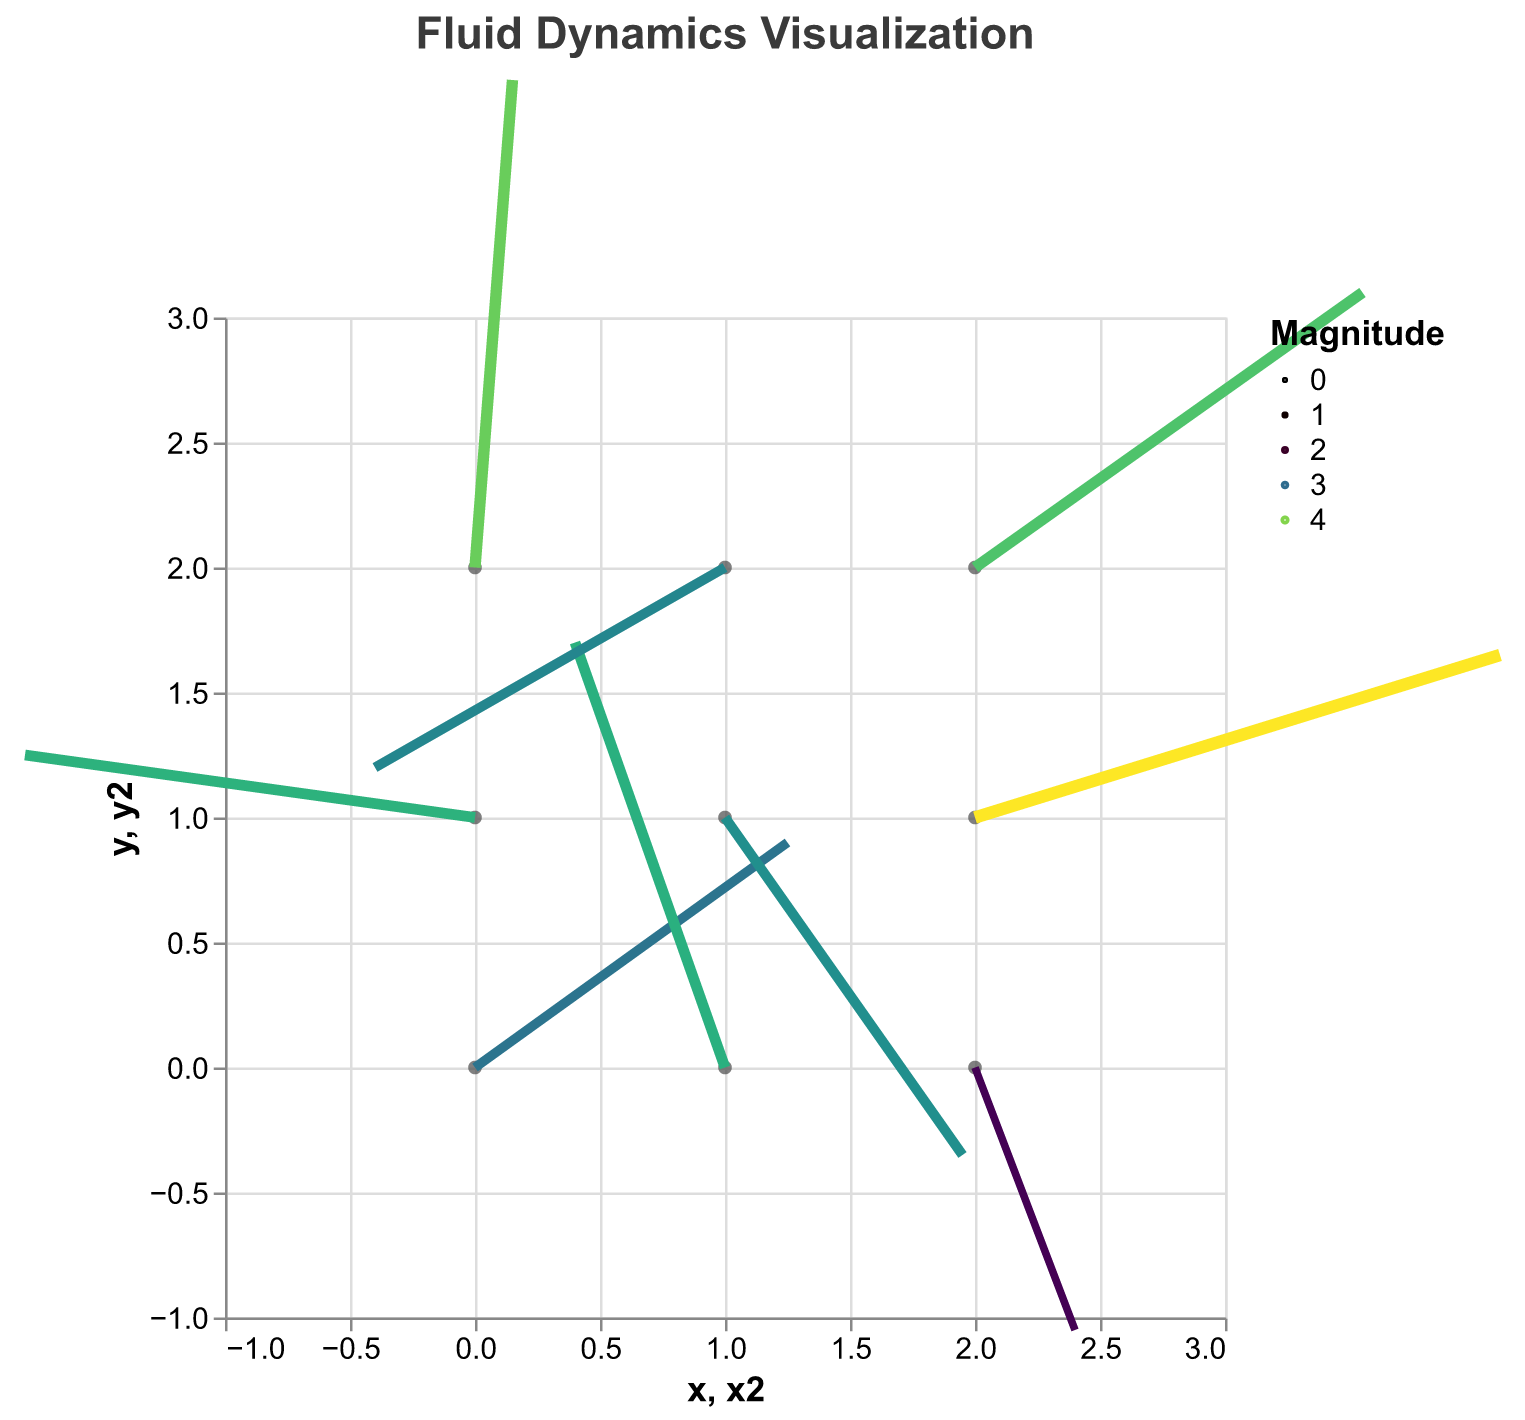What is the title of the figure? The title of the figure is displayed at the top and it reads "Fluid Dynamics Visualization".
Answer: Fluid Dynamics Visualization How many data points are shown in the quiver plot? By looking at the points where the arrows originate, we can count 9 data points.
Answer: 9 Which axis has the arrow pointing towards the highest positive u-value? The highest positive u-value corresponds to the arrow starting at (2, 1) with u = 4.2. The x-axis has the highest positive u-value.
Answer: x-axis What is the range of values represented by the magnitude legend? The legend for magnitude uses a color scheme ranging from the minimum magnitude of 2.25 to the maximum magnitude of 4.40.
Answer: 2.25 to 4.40 Which data point has the arrow with the highest magnitude? Find the data point with the highest magnitude from the dataset. The data point (2, 1) has the highest magnitude of 4.40.
Answer: (2, 1) Compare the directions of the arrows starting from (0, 0) and (1, 0). Which one has a larger direction value? The direction of the arrow starting from (0, 0) is 35.75 degrees, while that from (1, 0) is 109.44 degrees. The latter is larger.
Answer: (1, 0) How does the color of the magnitude indicator change as the magnitude increases? The color changes according to the Viridis color scheme, typically going from purple to yellow as the magnitude increases.
Answer: From purple to yellow What is the overall direction of the flow at (0, 2)? The direction at point (0, 2) with u = 0.3, v = 3.9 is 85.61 degrees, which suggests a northeast direction.
Answer: Northeast Which vector has the steepest downward direction? The vector at (2, 0) with direction 290.85 degrees has the steepest downward direction as it is below 360 degrees.
Answer: (2, 0) 